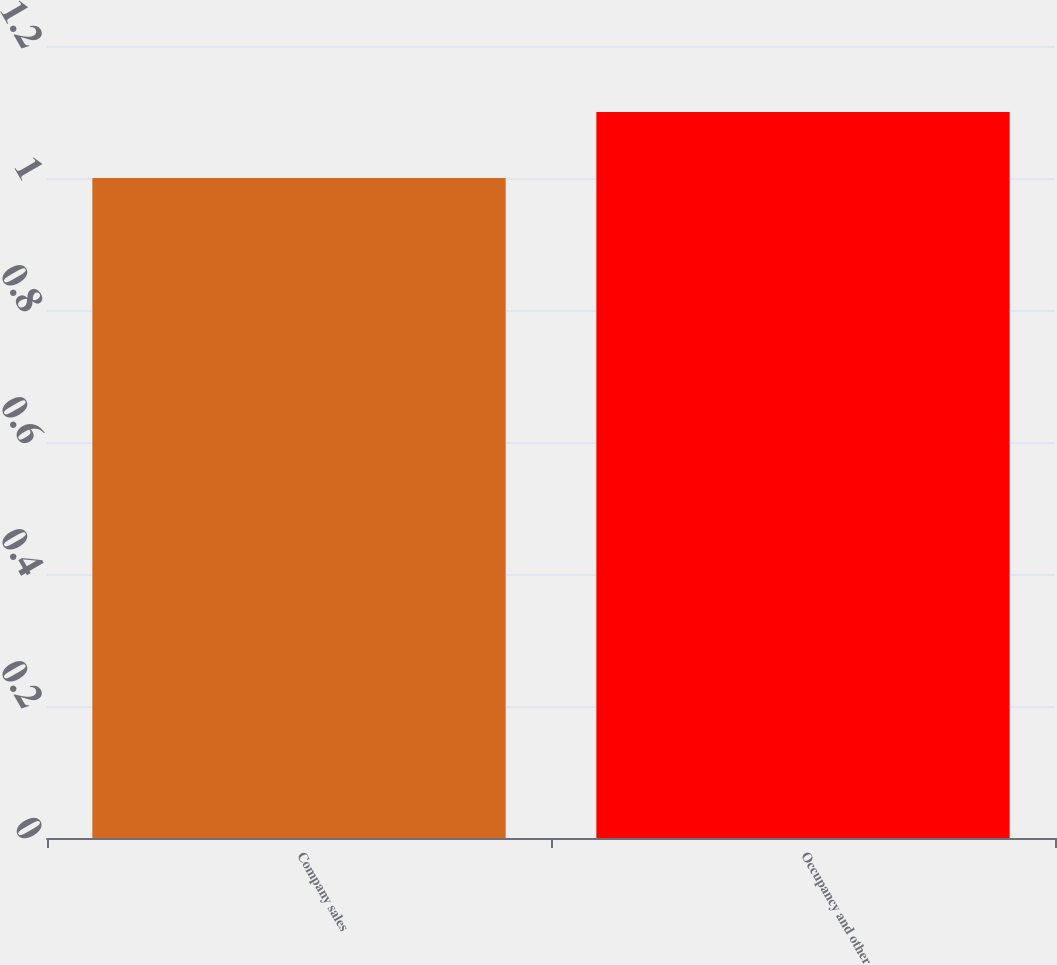Convert chart to OTSL. <chart><loc_0><loc_0><loc_500><loc_500><bar_chart><fcel>Company sales<fcel>Occupancy and other<nl><fcel>1<fcel>1.1<nl></chart> 